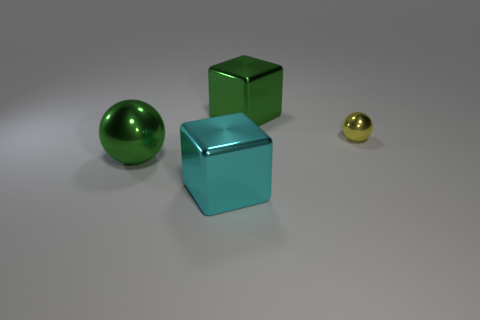Is there anything else that has the same size as the yellow shiny sphere?
Give a very brief answer. No. Do the large shiny ball and the large cube behind the small shiny sphere have the same color?
Ensure brevity in your answer.  Yes. Is the number of yellow objects less than the number of large yellow metallic balls?
Offer a terse response. No. What is the size of the thing that is both in front of the large green cube and behind the green metal ball?
Provide a succinct answer. Small. There is a metallic thing behind the small yellow ball; is it the same color as the large shiny sphere?
Your answer should be compact. Yes. Is the number of yellow balls that are left of the yellow sphere less than the number of tiny shiny objects?
Keep it short and to the point. Yes. The large cyan thing that is made of the same material as the yellow thing is what shape?
Make the answer very short. Cube. Does the large cyan cube have the same material as the big ball?
Give a very brief answer. Yes. Are there fewer tiny balls behind the green sphere than large cyan objects that are right of the yellow metal object?
Ensure brevity in your answer.  No. There is a block that is the same color as the big shiny ball; what is its size?
Your response must be concise. Large. 